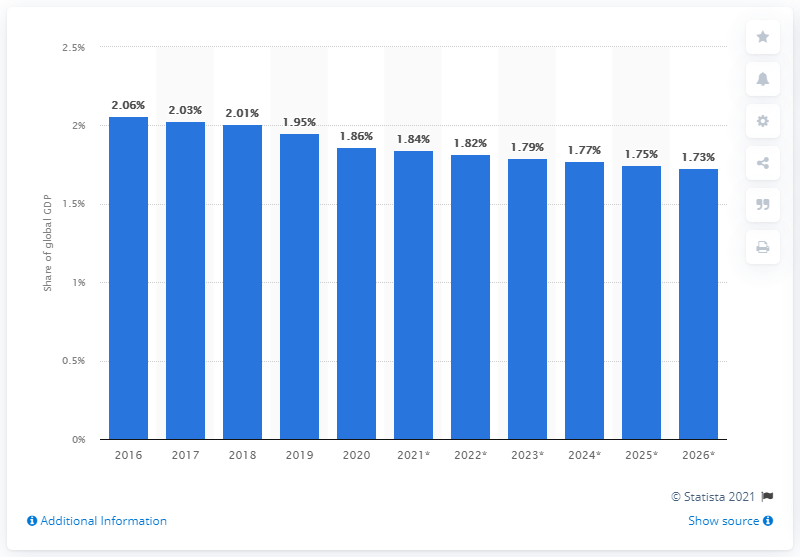Indicate a few pertinent items in this graphic. In 2020, Mexico's share of the global GDP was 1.86%. 